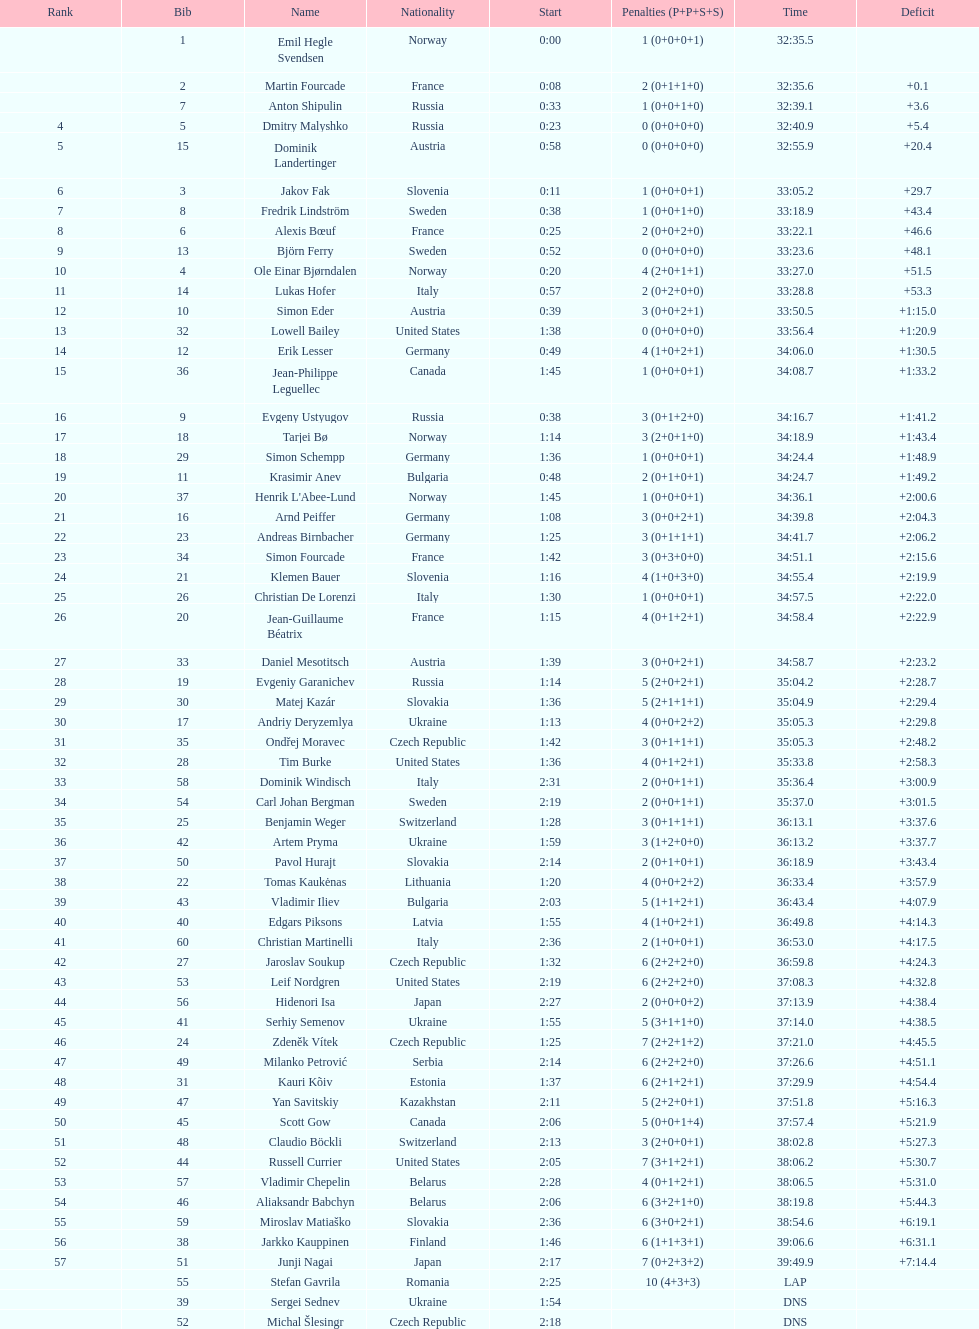Who is the top ranked runner of sweden? Fredrik Lindström. 